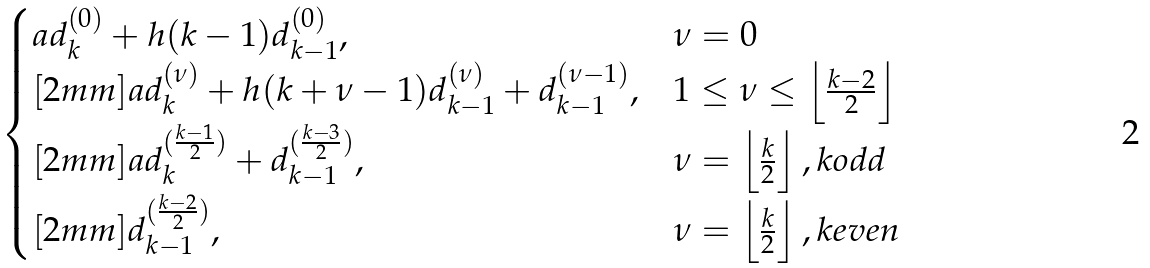<formula> <loc_0><loc_0><loc_500><loc_500>\begin{cases} a d _ { k } ^ { ( 0 ) } + h ( k - 1 ) d _ { k - 1 } ^ { ( 0 ) } , & \nu = 0 \\ [ 2 m m ] a d _ { k } ^ { ( \nu ) } + h ( k + \nu - 1 ) d _ { k - 1 } ^ { ( \nu ) } + d _ { k - 1 } ^ { ( \nu - 1 ) } , & 1 \leq \nu \leq \left \lfloor \frac { k - 2 } { 2 } \right \rfloor \\ [ 2 m m ] a d _ { k } ^ { ( \frac { k - 1 } { 2 } ) } + d _ { k - 1 } ^ { ( \frac { k - 3 } { 2 } ) } , & \nu = \left \lfloor \frac { k } { 2 } \right \rfloor , k o d d \\ [ 2 m m ] d _ { k - 1 } ^ { ( \frac { k - 2 } { 2 } ) } , & \nu = \left \lfloor \frac { k } { 2 } \right \rfloor , k e v e n \end{cases}</formula> 